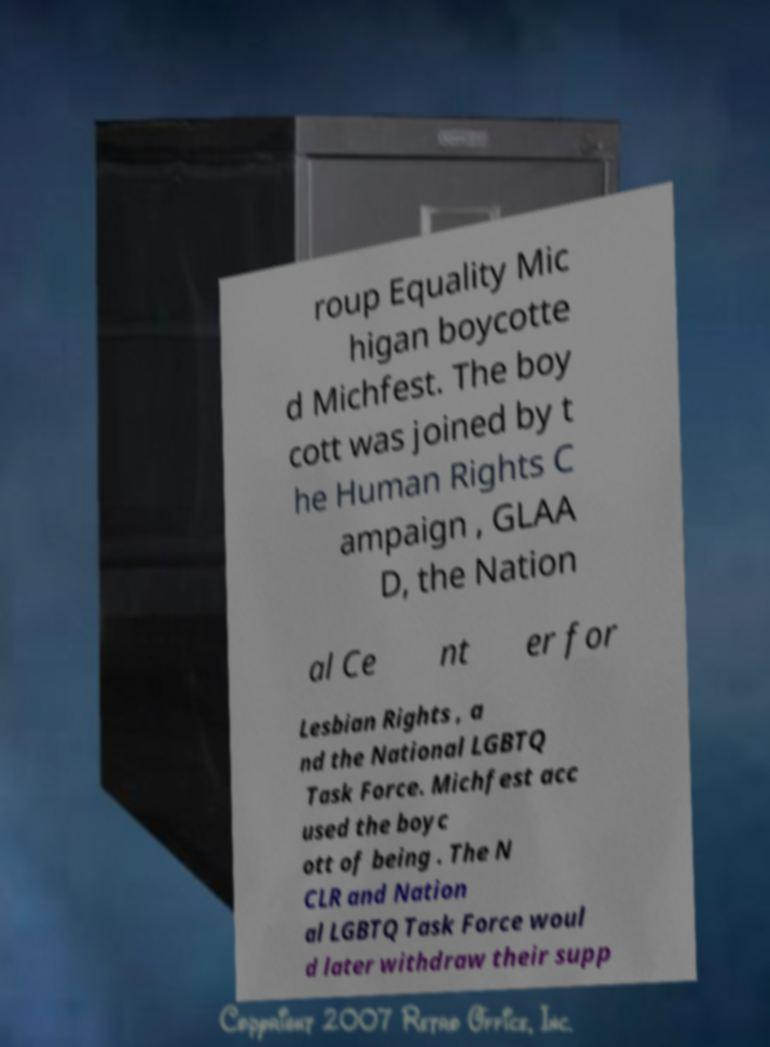Can you read and provide the text displayed in the image?This photo seems to have some interesting text. Can you extract and type it out for me? roup Equality Mic higan boycotte d Michfest. The boy cott was joined by t he Human Rights C ampaign , GLAA D, the Nation al Ce nt er for Lesbian Rights , a nd the National LGBTQ Task Force. Michfest acc used the boyc ott of being . The N CLR and Nation al LGBTQ Task Force woul d later withdraw their supp 